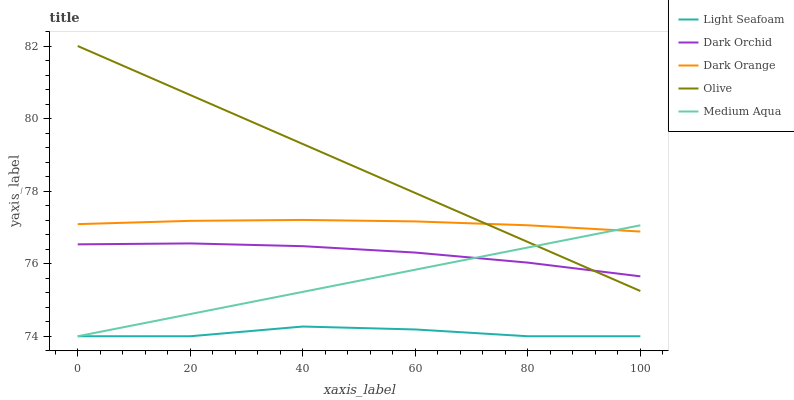Does Light Seafoam have the minimum area under the curve?
Answer yes or no. Yes. Does Olive have the maximum area under the curve?
Answer yes or no. Yes. Does Dark Orange have the minimum area under the curve?
Answer yes or no. No. Does Dark Orange have the maximum area under the curve?
Answer yes or no. No. Is Olive the smoothest?
Answer yes or no. Yes. Is Light Seafoam the roughest?
Answer yes or no. Yes. Is Dark Orange the smoothest?
Answer yes or no. No. Is Dark Orange the roughest?
Answer yes or no. No. Does Light Seafoam have the lowest value?
Answer yes or no. Yes. Does Dark Orange have the lowest value?
Answer yes or no. No. Does Olive have the highest value?
Answer yes or no. Yes. Does Dark Orange have the highest value?
Answer yes or no. No. Is Light Seafoam less than Olive?
Answer yes or no. Yes. Is Dark Orange greater than Light Seafoam?
Answer yes or no. Yes. Does Medium Aqua intersect Light Seafoam?
Answer yes or no. Yes. Is Medium Aqua less than Light Seafoam?
Answer yes or no. No. Is Medium Aqua greater than Light Seafoam?
Answer yes or no. No. Does Light Seafoam intersect Olive?
Answer yes or no. No. 